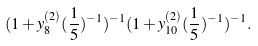<formula> <loc_0><loc_0><loc_500><loc_500>( 1 + y ^ { ( 2 ) } _ { 8 } ( \frac { 1 } { 5 } ) ^ { - 1 } ) ^ { - 1 } ( 1 + y ^ { ( 2 ) } _ { 1 0 } ( \frac { 1 } { 5 } ) ^ { - 1 } ) ^ { - 1 } .</formula> 